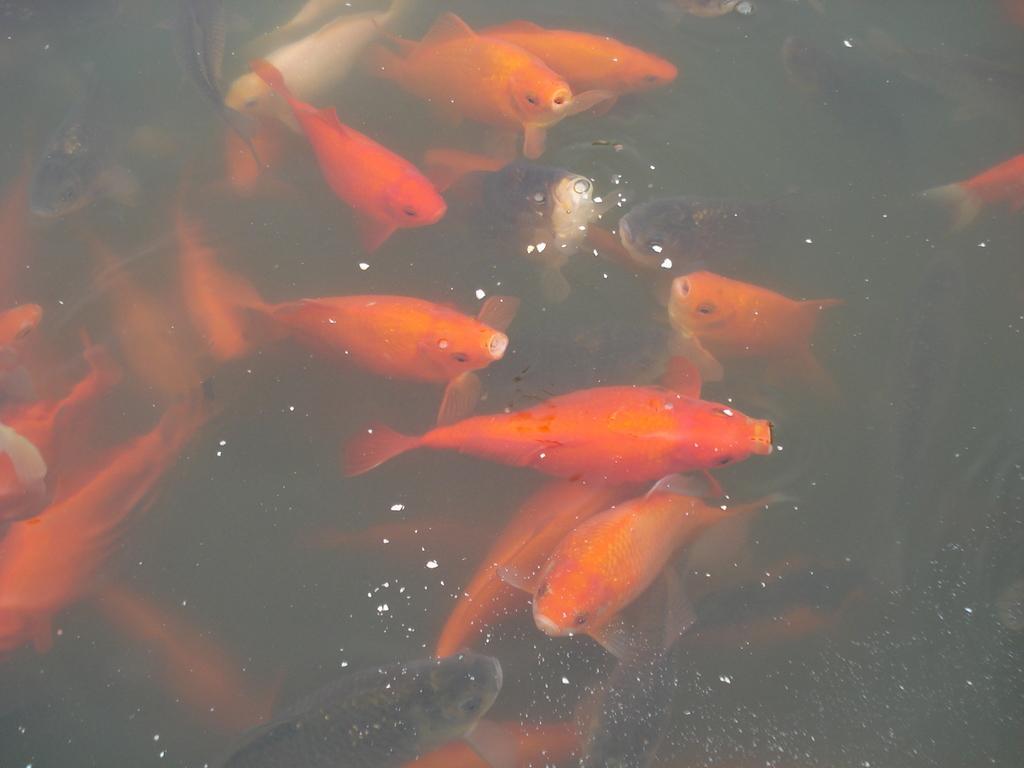How would you summarize this image in a sentence or two? In this image there are some fishes in the water, and there is some dust in the water. 